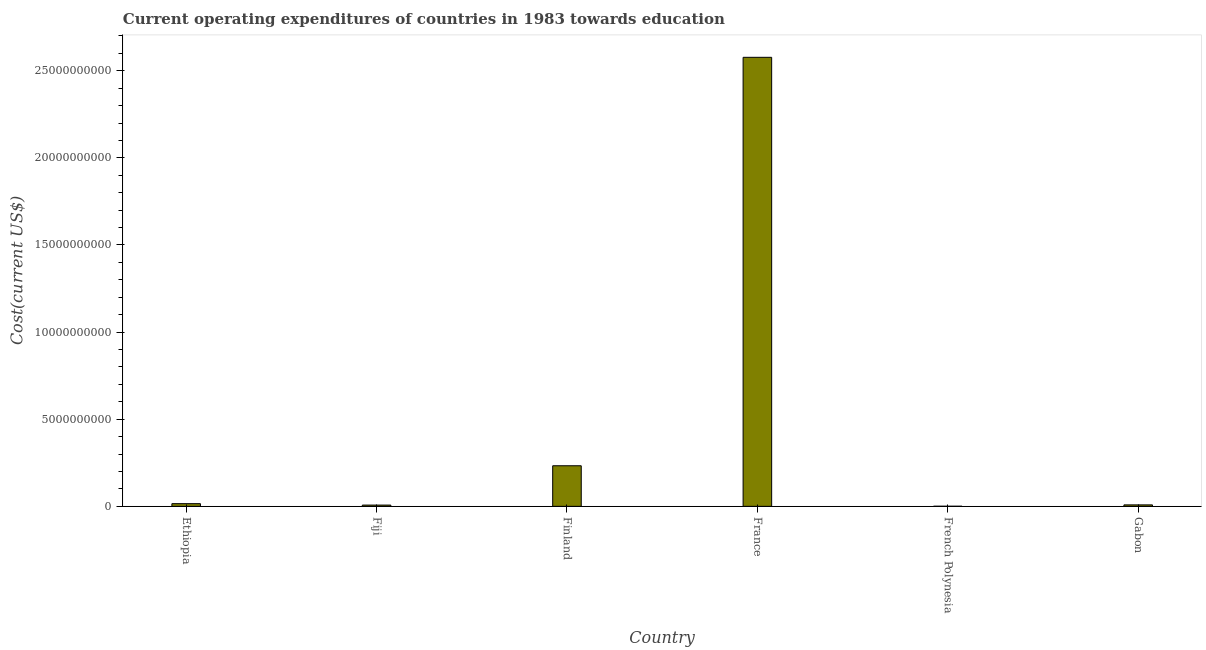Does the graph contain any zero values?
Offer a very short reply. No. What is the title of the graph?
Provide a succinct answer. Current operating expenditures of countries in 1983 towards education. What is the label or title of the X-axis?
Offer a very short reply. Country. What is the label or title of the Y-axis?
Your response must be concise. Cost(current US$). What is the education expenditure in French Polynesia?
Provide a succinct answer. 5.56e+06. Across all countries, what is the maximum education expenditure?
Keep it short and to the point. 2.58e+1. Across all countries, what is the minimum education expenditure?
Keep it short and to the point. 5.56e+06. In which country was the education expenditure maximum?
Make the answer very short. France. In which country was the education expenditure minimum?
Give a very brief answer. French Polynesia. What is the sum of the education expenditure?
Your answer should be very brief. 2.84e+1. What is the difference between the education expenditure in Fiji and France?
Offer a very short reply. -2.57e+1. What is the average education expenditure per country?
Provide a succinct answer. 4.74e+09. What is the median education expenditure?
Your response must be concise. 1.19e+08. In how many countries, is the education expenditure greater than 10000000000 US$?
Your response must be concise. 1. What is the ratio of the education expenditure in Fiji to that in Finland?
Ensure brevity in your answer.  0.03. Is the education expenditure in Fiji less than that in French Polynesia?
Ensure brevity in your answer.  No. Is the difference between the education expenditure in French Polynesia and Gabon greater than the difference between any two countries?
Provide a succinct answer. No. What is the difference between the highest and the second highest education expenditure?
Your answer should be very brief. 2.34e+1. Is the sum of the education expenditure in Fiji and French Polynesia greater than the maximum education expenditure across all countries?
Make the answer very short. No. What is the difference between the highest and the lowest education expenditure?
Keep it short and to the point. 2.58e+1. How many bars are there?
Give a very brief answer. 6. Are all the bars in the graph horizontal?
Offer a very short reply. No. How many countries are there in the graph?
Your response must be concise. 6. What is the difference between two consecutive major ticks on the Y-axis?
Give a very brief answer. 5.00e+09. Are the values on the major ticks of Y-axis written in scientific E-notation?
Your answer should be compact. No. What is the Cost(current US$) of Ethiopia?
Keep it short and to the point. 1.54e+08. What is the Cost(current US$) in Fiji?
Provide a short and direct response. 7.23e+07. What is the Cost(current US$) in Finland?
Your answer should be compact. 2.33e+09. What is the Cost(current US$) in France?
Give a very brief answer. 2.58e+1. What is the Cost(current US$) of French Polynesia?
Provide a short and direct response. 5.56e+06. What is the Cost(current US$) in Gabon?
Your answer should be compact. 8.36e+07. What is the difference between the Cost(current US$) in Ethiopia and Fiji?
Ensure brevity in your answer.  8.17e+07. What is the difference between the Cost(current US$) in Ethiopia and Finland?
Provide a short and direct response. -2.18e+09. What is the difference between the Cost(current US$) in Ethiopia and France?
Give a very brief answer. -2.56e+1. What is the difference between the Cost(current US$) in Ethiopia and French Polynesia?
Your answer should be compact. 1.48e+08. What is the difference between the Cost(current US$) in Ethiopia and Gabon?
Provide a short and direct response. 7.04e+07. What is the difference between the Cost(current US$) in Fiji and Finland?
Offer a terse response. -2.26e+09. What is the difference between the Cost(current US$) in Fiji and France?
Make the answer very short. -2.57e+1. What is the difference between the Cost(current US$) in Fiji and French Polynesia?
Keep it short and to the point. 6.67e+07. What is the difference between the Cost(current US$) in Fiji and Gabon?
Your answer should be compact. -1.13e+07. What is the difference between the Cost(current US$) in Finland and France?
Offer a very short reply. -2.34e+1. What is the difference between the Cost(current US$) in Finland and French Polynesia?
Give a very brief answer. 2.32e+09. What is the difference between the Cost(current US$) in Finland and Gabon?
Ensure brevity in your answer.  2.25e+09. What is the difference between the Cost(current US$) in France and French Polynesia?
Ensure brevity in your answer.  2.58e+1. What is the difference between the Cost(current US$) in France and Gabon?
Your response must be concise. 2.57e+1. What is the difference between the Cost(current US$) in French Polynesia and Gabon?
Your answer should be compact. -7.80e+07. What is the ratio of the Cost(current US$) in Ethiopia to that in Fiji?
Your response must be concise. 2.13. What is the ratio of the Cost(current US$) in Ethiopia to that in Finland?
Your answer should be compact. 0.07. What is the ratio of the Cost(current US$) in Ethiopia to that in France?
Make the answer very short. 0.01. What is the ratio of the Cost(current US$) in Ethiopia to that in French Polynesia?
Provide a succinct answer. 27.71. What is the ratio of the Cost(current US$) in Ethiopia to that in Gabon?
Give a very brief answer. 1.84. What is the ratio of the Cost(current US$) in Fiji to that in Finland?
Offer a terse response. 0.03. What is the ratio of the Cost(current US$) in Fiji to that in France?
Make the answer very short. 0. What is the ratio of the Cost(current US$) in Fiji to that in French Polynesia?
Offer a terse response. 13. What is the ratio of the Cost(current US$) in Fiji to that in Gabon?
Your response must be concise. 0.86. What is the ratio of the Cost(current US$) in Finland to that in France?
Provide a succinct answer. 0.09. What is the ratio of the Cost(current US$) in Finland to that in French Polynesia?
Offer a terse response. 419.21. What is the ratio of the Cost(current US$) in Finland to that in Gabon?
Provide a succinct answer. 27.86. What is the ratio of the Cost(current US$) in France to that in French Polynesia?
Your answer should be very brief. 4637.97. What is the ratio of the Cost(current US$) in France to that in Gabon?
Provide a succinct answer. 308.25. What is the ratio of the Cost(current US$) in French Polynesia to that in Gabon?
Give a very brief answer. 0.07. 